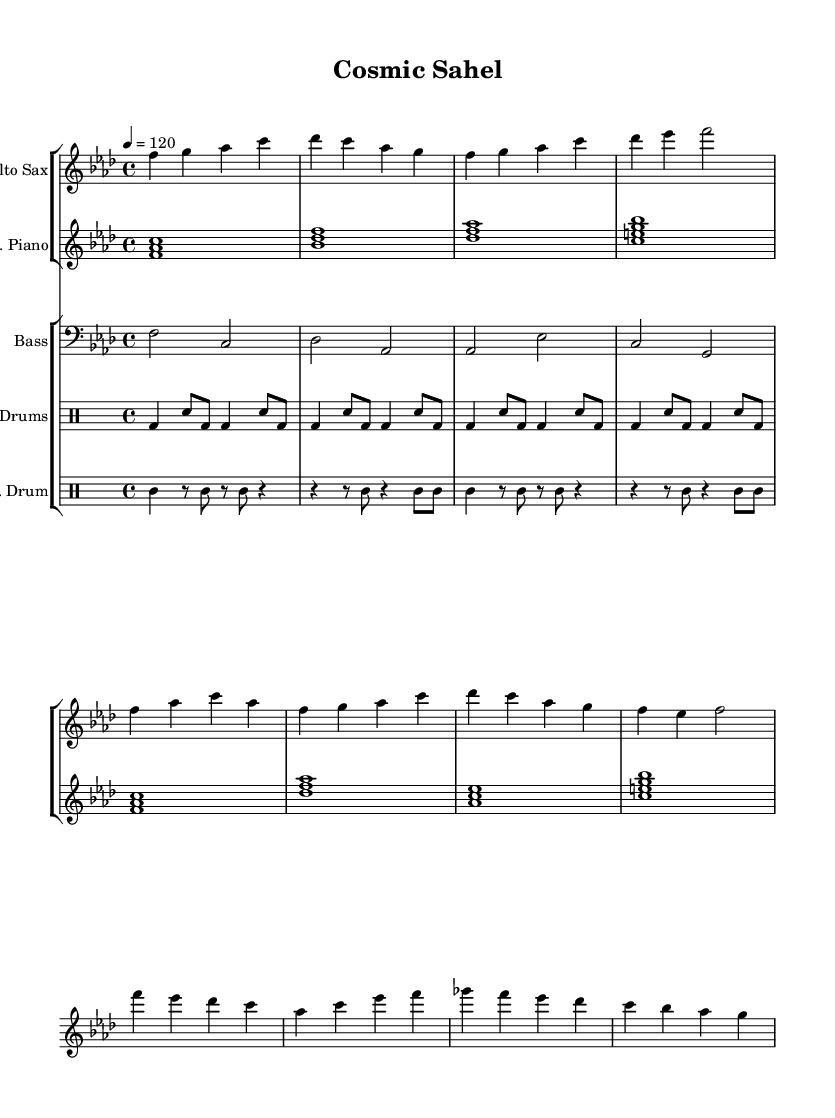What is the key signature of this music? The key signature of the piece is F minor, which has four flats (B, E, A, D). This can be identified in the global section of the LilyPond code under the line "\key f \minor".
Answer: F minor What is the time signature of the music? The time signature is indicated as 4/4, meaning there are four beats in each measure and the quarter note receives one beat. This is found in the global section of the code under "\time 4/4".
Answer: 4/4 What is the tempo of the piece? The tempo is specified as quarter note equals 120 beats per minute, which indicates the speed of the performance. This is found in the global section of the code under "\tempo 4 = 120".
Answer: 120 How many measures are in the intro section? The intro section of the alto sax part consists of four measures. This can be counted in the provided notes from the start of the part until the end of that section.
Answer: 4 Which instruments are featured in this piece? The piece features the alto sax, electric piano, bass guitar, drum kit, and talking drum. This can be determined from the score's staff lineup where each instrument is indicated.
Answer: Alto Sax, E. Piano, Bass, Drums, T. Drum What role do the talking drums play in this composition? The talking drums provide rhythm, complementing the drum kit and enhancing the performance with traditional African elements. They have their own dedicated staff showing their unique patterns in the score.
Answer: Rhythm reinforcement Is there a central theme established in the verse? Yes, the verse develops a melodic line that frequently returns to the note F, establishing it as a tonal center throughout the section, which can be identified by patterns in the alto sax part.
Answer: F 